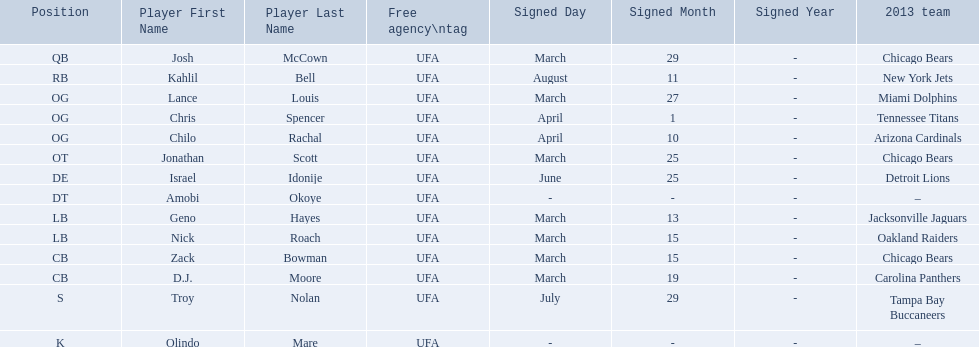Who are all the players on the 2013 chicago bears season team? Josh McCown, Kahlil Bell, Lance Louis, Chris Spencer, Chilo Rachal, Jonathan Scott, Israel Idonije, Amobi Okoye, Geno Hayes, Nick Roach, Zack Bowman, D. J. Moore, Troy Nolan, Olindo Mare. What day was nick roach signed? March 15. What other day matches this? March 15. Who was signed on the day? Zack Bowman. 